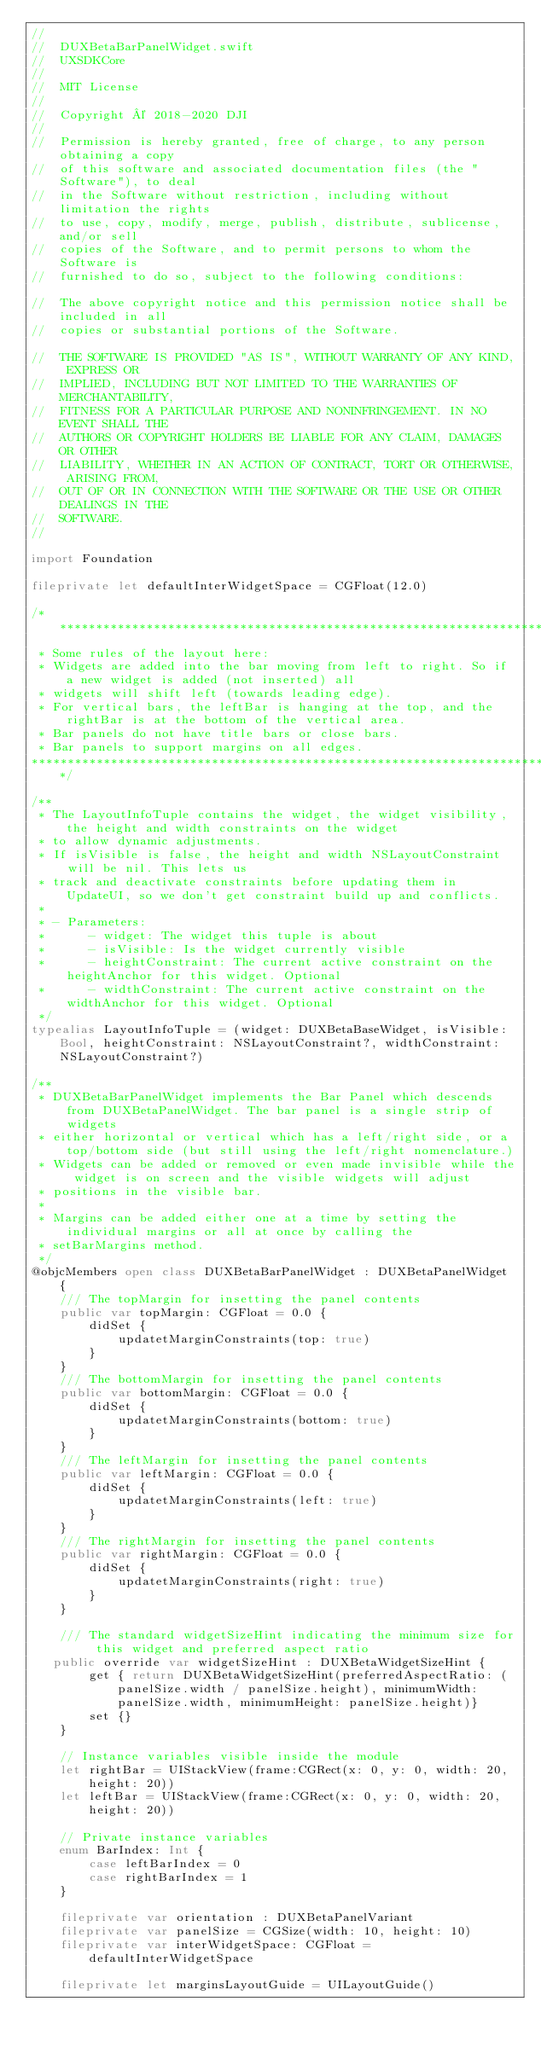Convert code to text. <code><loc_0><loc_0><loc_500><loc_500><_Swift_>//
//  DUXBetaBarPanelWidget.swift
//  UXSDKCore
//
//  MIT License
//  
//  Copyright © 2018-2020 DJI
//  
//  Permission is hereby granted, free of charge, to any person obtaining a copy
//  of this software and associated documentation files (the "Software"), to deal
//  in the Software without restriction, including without limitation the rights
//  to use, copy, modify, merge, publish, distribute, sublicense, and/or sell
//  copies of the Software, and to permit persons to whom the Software is
//  furnished to do so, subject to the following conditions:

//  The above copyright notice and this permission notice shall be included in all
//  copies or substantial portions of the Software.

//  THE SOFTWARE IS PROVIDED "AS IS", WITHOUT WARRANTY OF ANY KIND, EXPRESS OR
//  IMPLIED, INCLUDING BUT NOT LIMITED TO THE WARRANTIES OF MERCHANTABILITY,
//  FITNESS FOR A PARTICULAR PURPOSE AND NONINFRINGEMENT. IN NO EVENT SHALL THE
//  AUTHORS OR COPYRIGHT HOLDERS BE LIABLE FOR ANY CLAIM, DAMAGES OR OTHER
//  LIABILITY, WHETHER IN AN ACTION OF CONTRACT, TORT OR OTHERWISE, ARISING FROM,
//  OUT OF OR IN CONNECTION WITH THE SOFTWARE OR THE USE OR OTHER DEALINGS IN THE
//  SOFTWARE.
//

import Foundation

fileprivate let defaultInterWidgetSpace = CGFloat(12.0)

/******************************************************************************
 * Some rules of the layout here:
 * Widgets are added into the bar moving from left to right. So if a new widget is added (not inserted) all
 * widgets will shift left (towards leading edge).
 * For vertical bars, the leftBar is hanging at the top, and the rightBar is at the bottom of the vertical area.
 * Bar panels do not have title bars or close bars.
 * Bar panels to support margins on all edges.
******************************************************************************/

/**
 * The LayoutInfoTuple contains the widget, the widget visibility, the height and width constraints on the widget
 * to allow dynamic adjustments.
 * If isVisible is false, the height and width NSLayoutConstraint will be nil. This lets us
 * track and deactivate constraints before updating them in UpdateUI, so we don't get constraint build up and conflicts.
 *
 * - Parameters:
 *      - widget: The widget this tuple is about
 *      - isVisible: Is the widget currently visible
 *      - heightConstraint: The current active constraint on the heightAnchor for this widget. Optional
 *      - widthConstraint: The current active constraint on the widthAnchor for this widget. Optional
 */
typealias LayoutInfoTuple = (widget: DUXBetaBaseWidget, isVisible: Bool, heightConstraint: NSLayoutConstraint?, widthConstraint: NSLayoutConstraint?)

/**
 * DUXBetaBarPanelWidget implements the Bar Panel which descends from DUXBetaPanelWidget. The bar panel is a single strip of widgets
 * either horizontal or vertical which has a left/right side, or a top/bottom side (but still using the left/right nomenclature.)
 * Widgets can be added or removed or even made invisible while the widget is on screen and the visible widgets will adjust
 * positions in the visible bar.
 *
 * Margins can be added either one at a time by setting the individual margins or all at once by calling the
 * setBarMargins method.
 */
@objcMembers open class DUXBetaBarPanelWidget : DUXBetaPanelWidget {
    /// The topMargin for insetting the panel contents
    public var topMargin: CGFloat = 0.0 {
        didSet {
            updatetMarginConstraints(top: true)
        }
    }
    /// The bottomMargin for insetting the panel contents
    public var bottomMargin: CGFloat = 0.0 {
        didSet {
            updatetMarginConstraints(bottom: true)
        }
    }
    /// The leftMargin for insetting the panel contents
    public var leftMargin: CGFloat = 0.0 {
        didSet {
            updatetMarginConstraints(left: true)
        }
    }
    /// The rightMargin for insetting the panel contents
    public var rightMargin: CGFloat = 0.0 {
        didSet {
            updatetMarginConstraints(right: true)
        }
    }

    /// The standard widgetSizeHint indicating the minimum size for this widget and preferred aspect ratio
   public override var widgetSizeHint : DUXBetaWidgetSizeHint {
        get { return DUXBetaWidgetSizeHint(preferredAspectRatio: (panelSize.width / panelSize.height), minimumWidth: panelSize.width, minimumHeight: panelSize.height)}
        set {}
    }
    
    // Instance variables visible inside the module
    let rightBar = UIStackView(frame:CGRect(x: 0, y: 0, width: 20, height: 20))
    let leftBar = UIStackView(frame:CGRect(x: 0, y: 0, width: 20, height: 20))

    // Private instance variables
    enum BarIndex: Int {
        case leftBarIndex = 0
        case rightBarIndex = 1
    }
    
    fileprivate var orientation : DUXBetaPanelVariant
    fileprivate var panelSize = CGSize(width: 10, height: 10)
    fileprivate var interWidgetSpace: CGFloat = defaultInterWidgetSpace
    
    fileprivate let marginsLayoutGuide = UILayoutGuide()</code> 